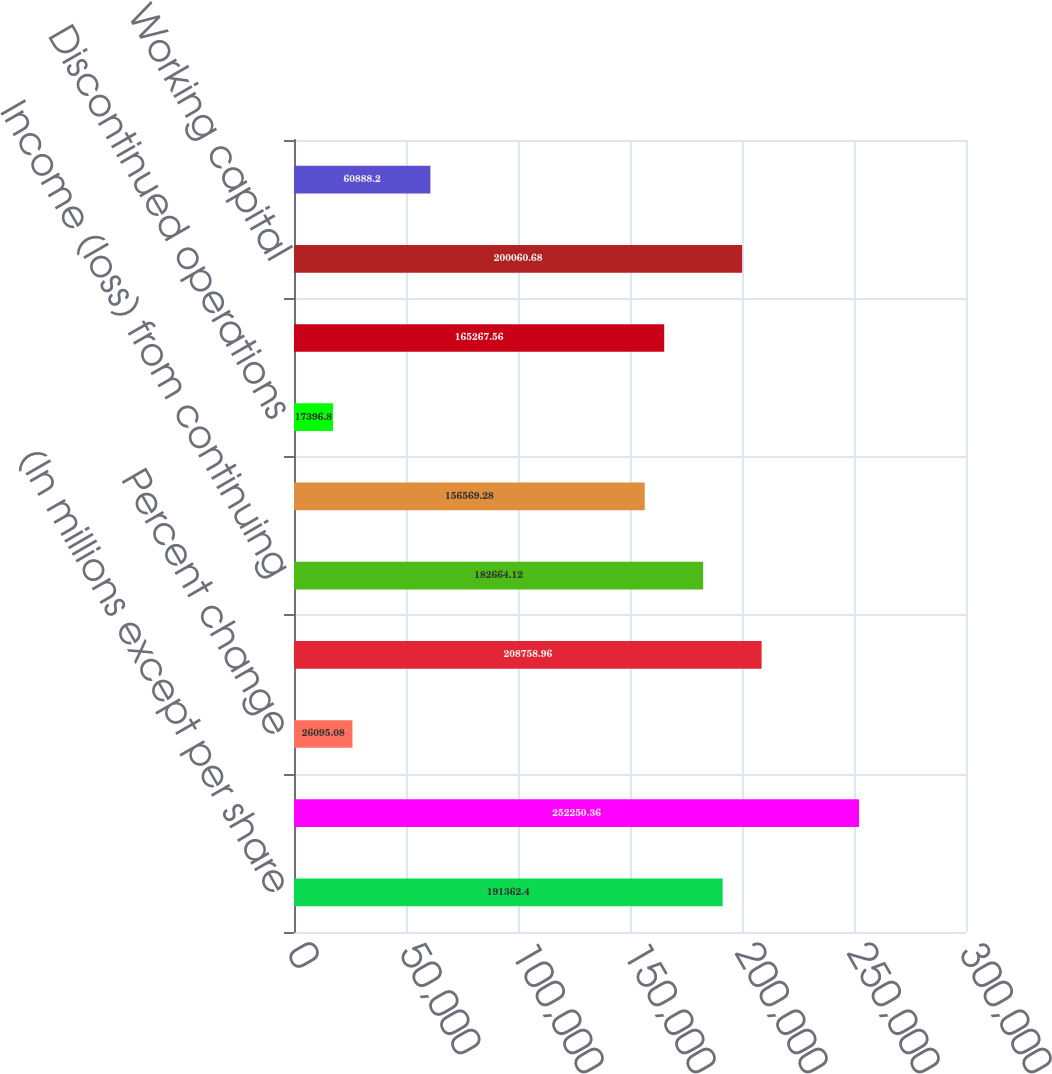Convert chart to OTSL. <chart><loc_0><loc_0><loc_500><loc_500><bar_chart><fcel>(In millions except per share<fcel>Revenues<fcel>Percent change<fcel>Gross profit<fcel>Income (loss) from continuing<fcel>Continuing operations<fcel>Discontinued operations<fcel>Net income (loss)<fcel>Working capital<fcel>Customer receivables<nl><fcel>191362<fcel>252250<fcel>26095.1<fcel>208759<fcel>182664<fcel>156569<fcel>17396.8<fcel>165268<fcel>200061<fcel>60888.2<nl></chart> 